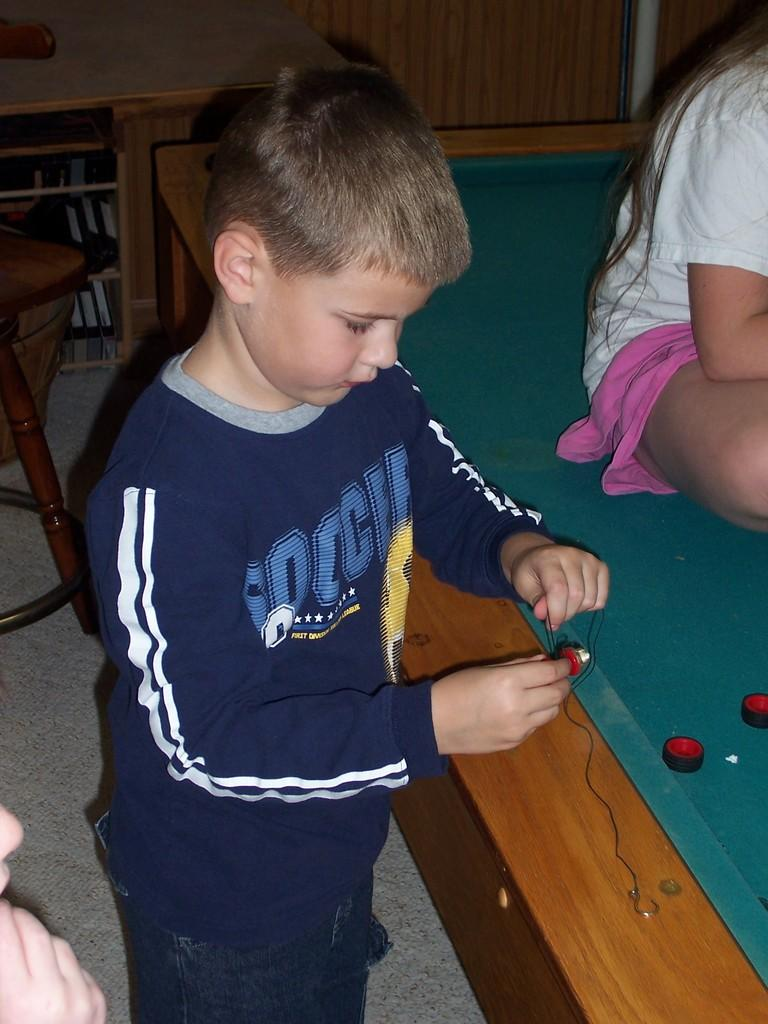What is the main subject of the image? The main subject of the image is a boy standing and doing something with wires or thread. Can you describe the girl's position in the image? The girl is sitting on a table in the image. What can be seen in the background of the image? There are racks with books and a wall visible in the background of the image. How many spiders are crawling on the books in the image? There are no spiders visible in the image; it only shows a boy, a girl, and racks with books. What type of memory is being used by the boy in the image? The image does not provide information about the type of memory being used by the boy; it only shows him doing something with wires or thread. 